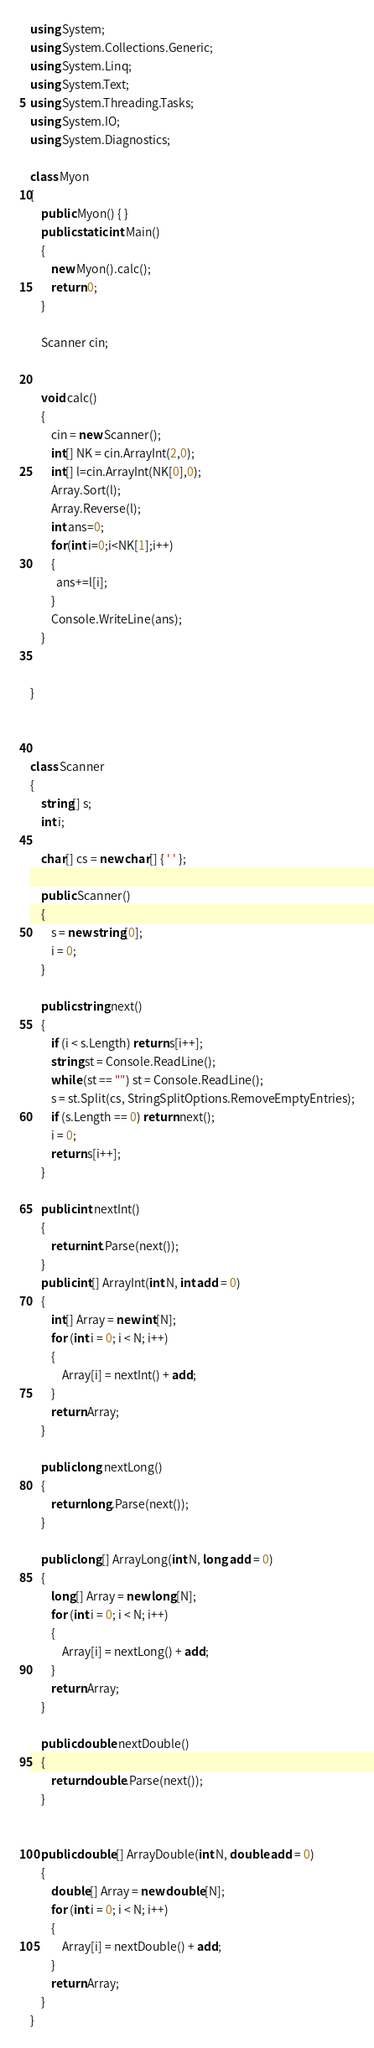Convert code to text. <code><loc_0><loc_0><loc_500><loc_500><_C#_>using System;
using System.Collections.Generic;
using System.Linq;
using System.Text;
using System.Threading.Tasks;
using System.IO;
using System.Diagnostics;

class Myon
{
    public Myon() { }
    public static int Main()
    {
        new Myon().calc();
        return 0;
    }

    Scanner cin;


    void calc()
    {
        cin = new Scanner();
        int[] NK = cin.ArrayInt(2,0);
        int[] l=cin.ArrayInt(NK[0],0);
        Array.Sort(l);
        Array.Reverse(l);
        int ans=0;
        for(int i=0;i<NK[1];i++)
        {
          ans+=l[i];
        }
        Console.WriteLine(ans);
    }


}



class Scanner
{
    string[] s;
    int i;

    char[] cs = new char[] { ' ' };

    public Scanner()
    {
        s = new string[0];
        i = 0;
    }

    public string next()
    {
        if (i < s.Length) return s[i++];
        string st = Console.ReadLine();
        while (st == "") st = Console.ReadLine();
        s = st.Split(cs, StringSplitOptions.RemoveEmptyEntries);
        if (s.Length == 0) return next();
        i = 0;
        return s[i++];
    }

    public int nextInt()
    {
        return int.Parse(next());
    }
    public int[] ArrayInt(int N, int add = 0)
    {
        int[] Array = new int[N];
        for (int i = 0; i < N; i++)
        {
            Array[i] = nextInt() + add;
        }
        return Array;
    }

    public long nextLong()
    {
        return long.Parse(next());
    }

    public long[] ArrayLong(int N, long add = 0)
    {
        long[] Array = new long[N];
        for (int i = 0; i < N; i++)
        {
            Array[i] = nextLong() + add;
        }
        return Array;
    }

    public double nextDouble()
    {
        return double.Parse(next());
    }


    public double[] ArrayDouble(int N, double add = 0)
    {
        double[] Array = new double[N];
        for (int i = 0; i < N; i++)
        {
            Array[i] = nextDouble() + add;
        }
        return Array;
    }
}</code> 